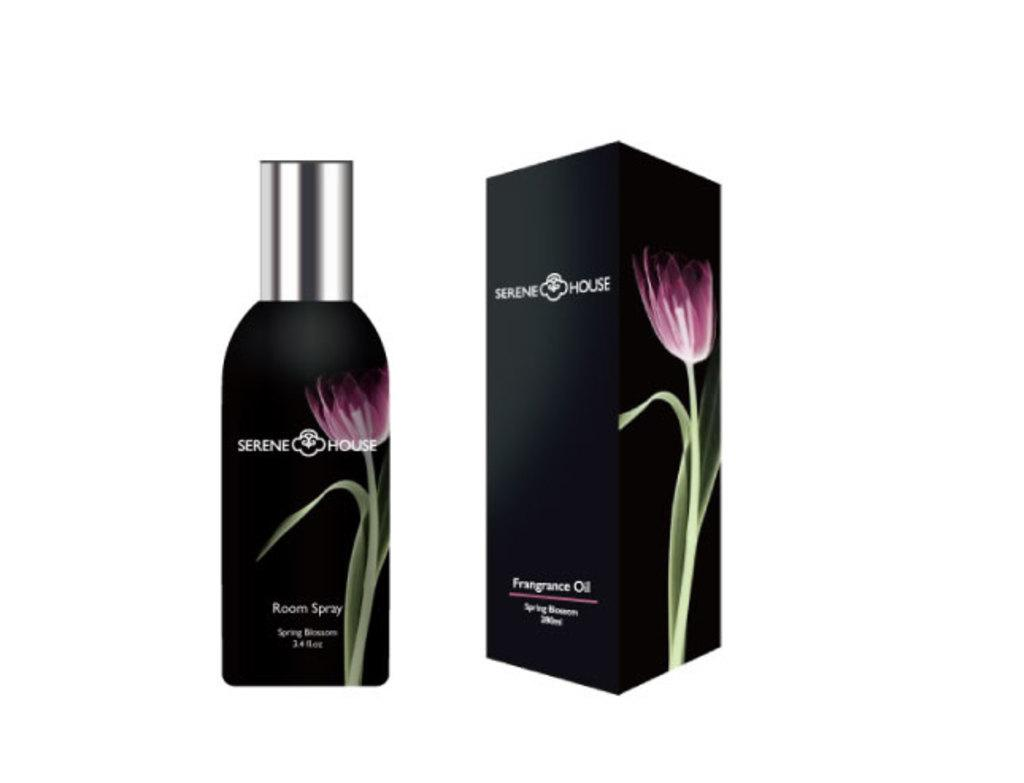<image>
Relay a brief, clear account of the picture shown. a box with the word serene on it 